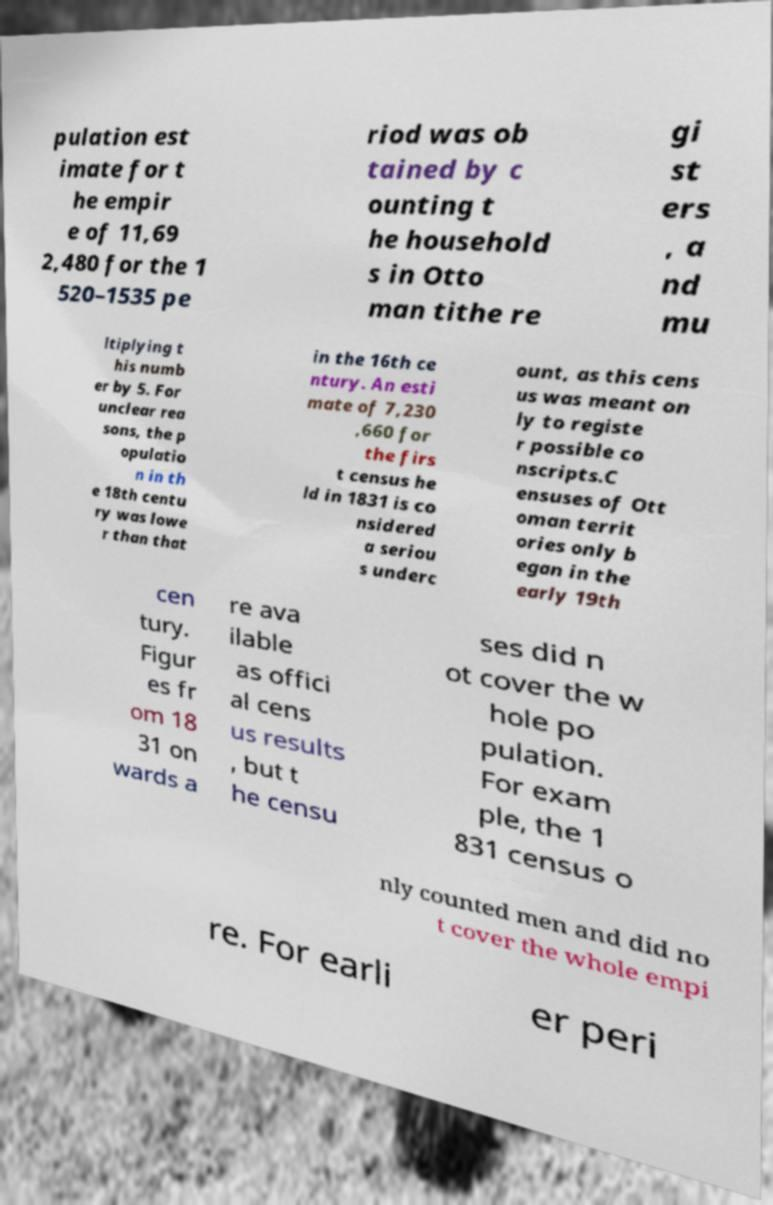I need the written content from this picture converted into text. Can you do that? pulation est imate for t he empir e of 11,69 2,480 for the 1 520–1535 pe riod was ob tained by c ounting t he household s in Otto man tithe re gi st ers , a nd mu ltiplying t his numb er by 5. For unclear rea sons, the p opulatio n in th e 18th centu ry was lowe r than that in the 16th ce ntury. An esti mate of 7,230 ,660 for the firs t census he ld in 1831 is co nsidered a seriou s underc ount, as this cens us was meant on ly to registe r possible co nscripts.C ensuses of Ott oman territ ories only b egan in the early 19th cen tury. Figur es fr om 18 31 on wards a re ava ilable as offici al cens us results , but t he censu ses did n ot cover the w hole po pulation. For exam ple, the 1 831 census o nly counted men and did no t cover the whole empi re. For earli er peri 